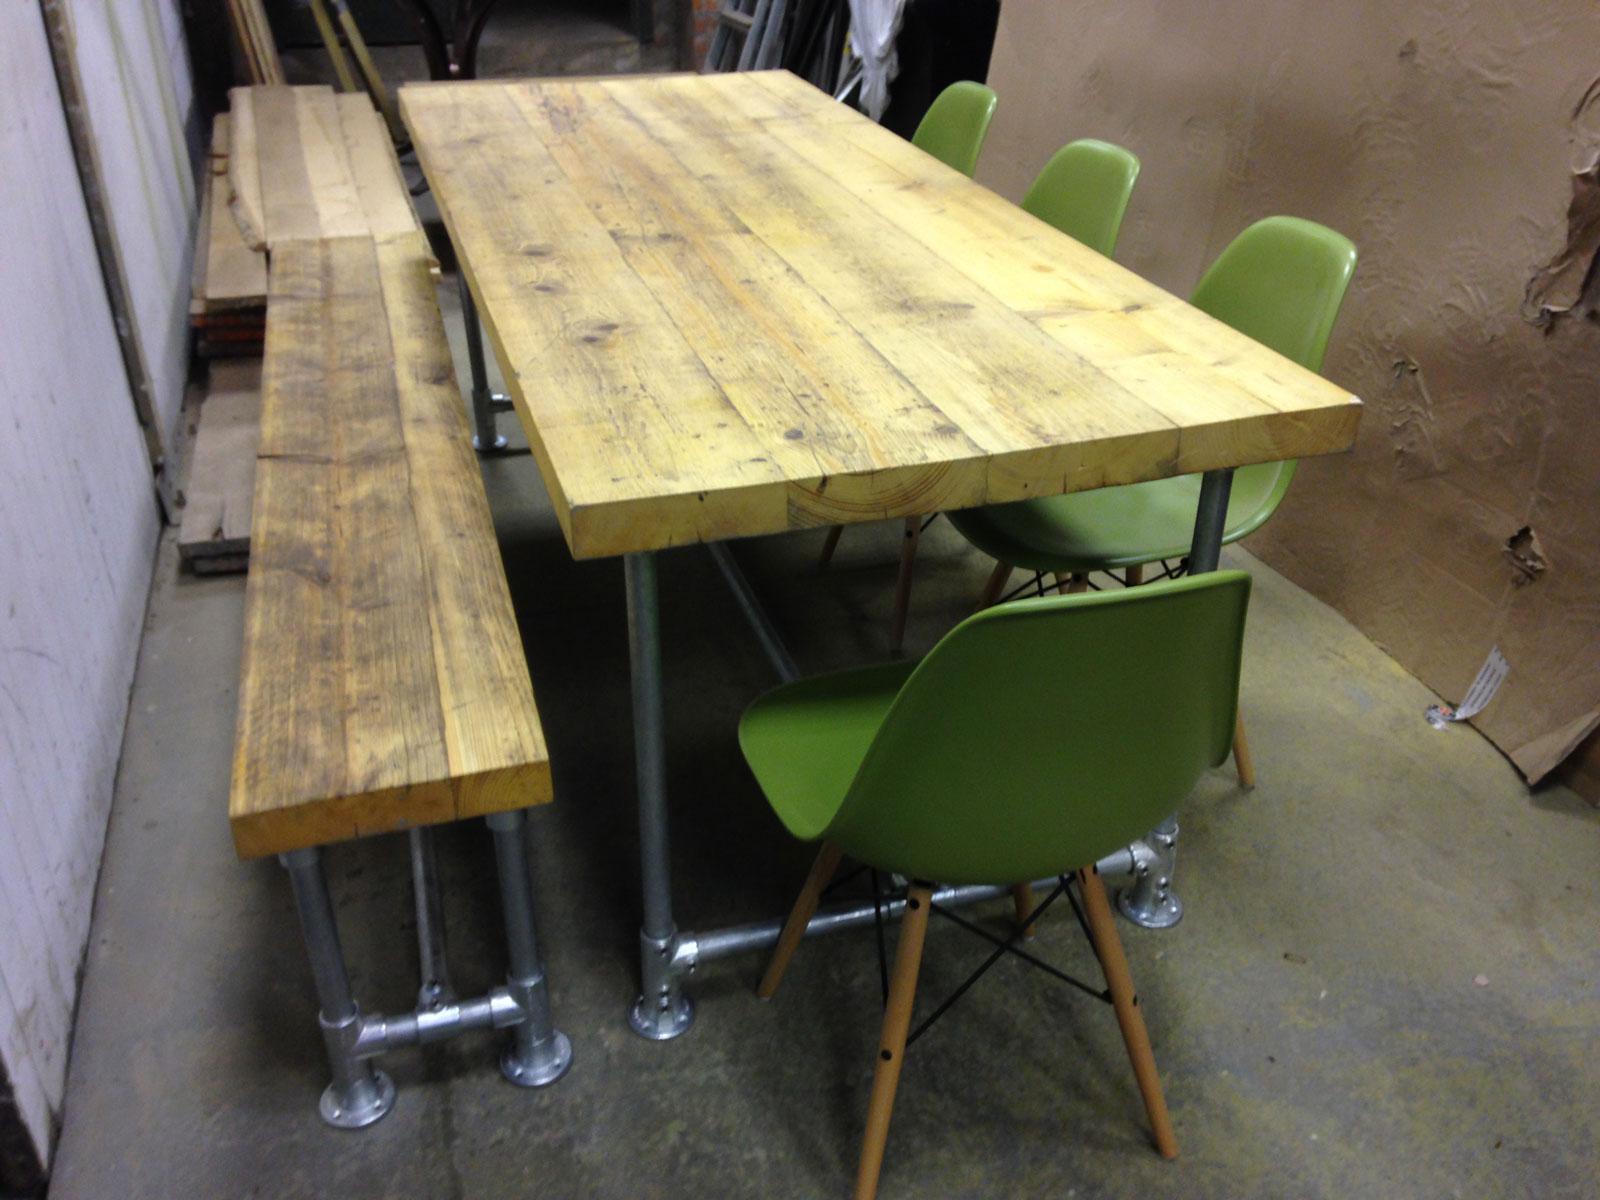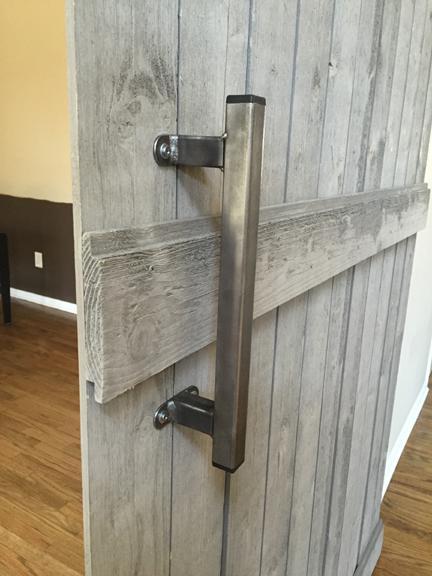The first image is the image on the left, the second image is the image on the right. Examine the images to the left and right. Is the description "There is a bench left of the table in one of the images" accurate? Answer yes or no. Yes. The first image is the image on the left, the second image is the image on the right. Given the left and right images, does the statement "One table has bench seating." hold true? Answer yes or no. Yes. 